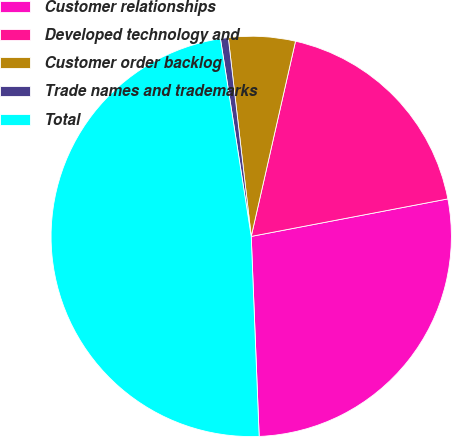<chart> <loc_0><loc_0><loc_500><loc_500><pie_chart><fcel>Customer relationships<fcel>Developed technology and<fcel>Customer order backlog<fcel>Trade names and trademarks<fcel>Total<nl><fcel>27.37%<fcel>18.45%<fcel>5.38%<fcel>0.63%<fcel>48.17%<nl></chart> 